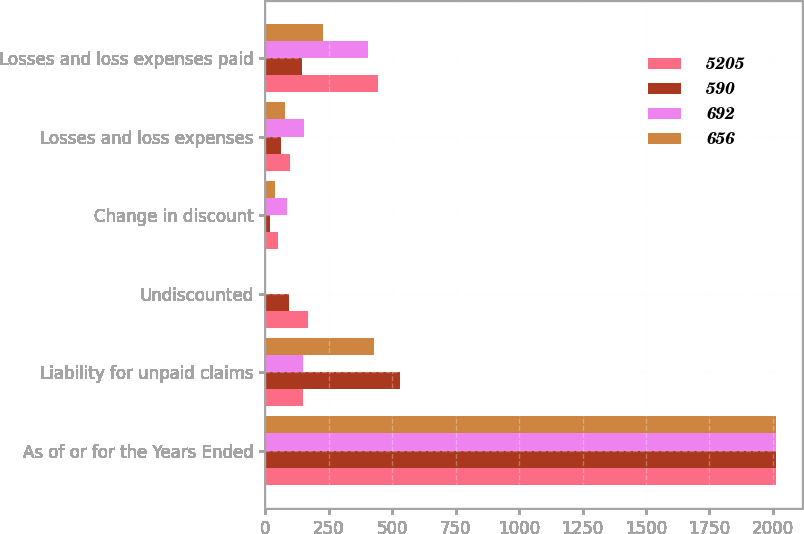Convert chart. <chart><loc_0><loc_0><loc_500><loc_500><stacked_bar_chart><ecel><fcel>As of or for the Years Ended<fcel>Liability for unpaid claims<fcel>Undiscounted<fcel>Change in discount<fcel>Losses and loss expenses<fcel>Losses and loss expenses paid<nl><fcel>5205<fcel>2013<fcel>147.5<fcel>169<fcel>51<fcel>98<fcel>444<nl><fcel>590<fcel>2013<fcel>529<fcel>92<fcel>18<fcel>61<fcel>145<nl><fcel>692<fcel>2012<fcel>147.5<fcel>1<fcel>83<fcel>150<fcel>404<nl><fcel>656<fcel>2012<fcel>427<fcel>1<fcel>37<fcel>75<fcel>228<nl></chart> 